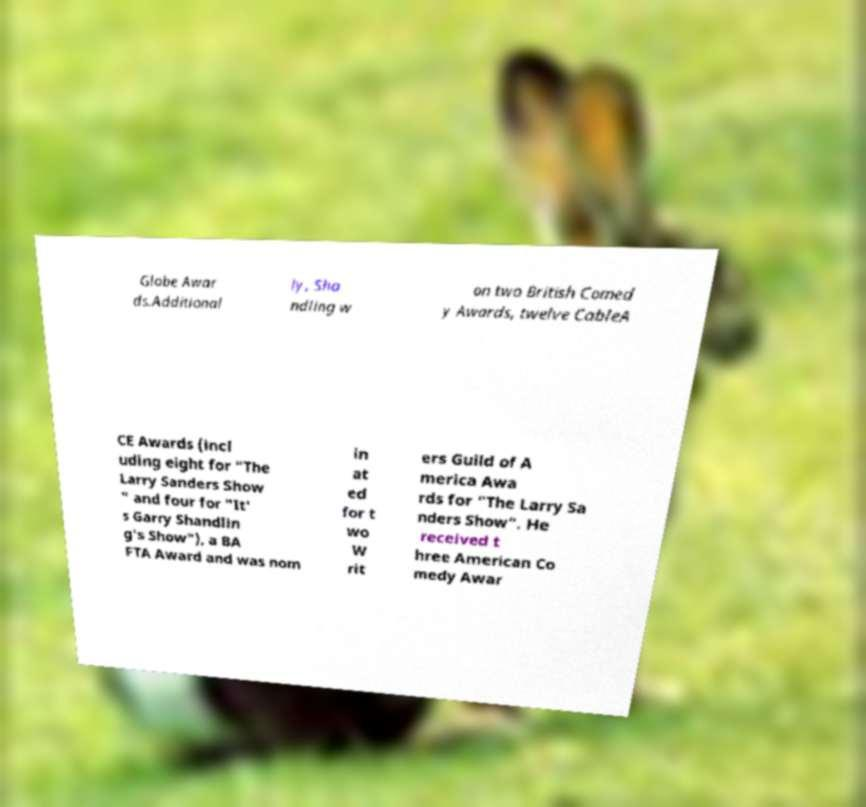Can you accurately transcribe the text from the provided image for me? Globe Awar ds.Additional ly, Sha ndling w on two British Comed y Awards, twelve CableA CE Awards (incl uding eight for "The Larry Sanders Show " and four for "It' s Garry Shandlin g's Show"), a BA FTA Award and was nom in at ed for t wo W rit ers Guild of A merica Awa rds for "The Larry Sa nders Show". He received t hree American Co medy Awar 